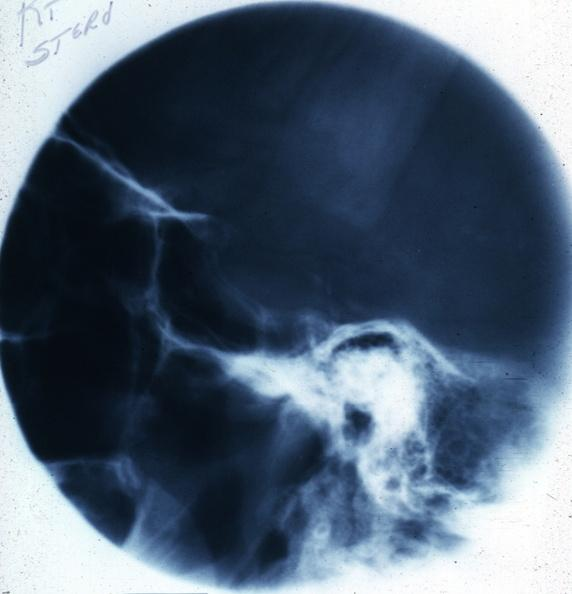s endocrine present?
Answer the question using a single word or phrase. Yes 